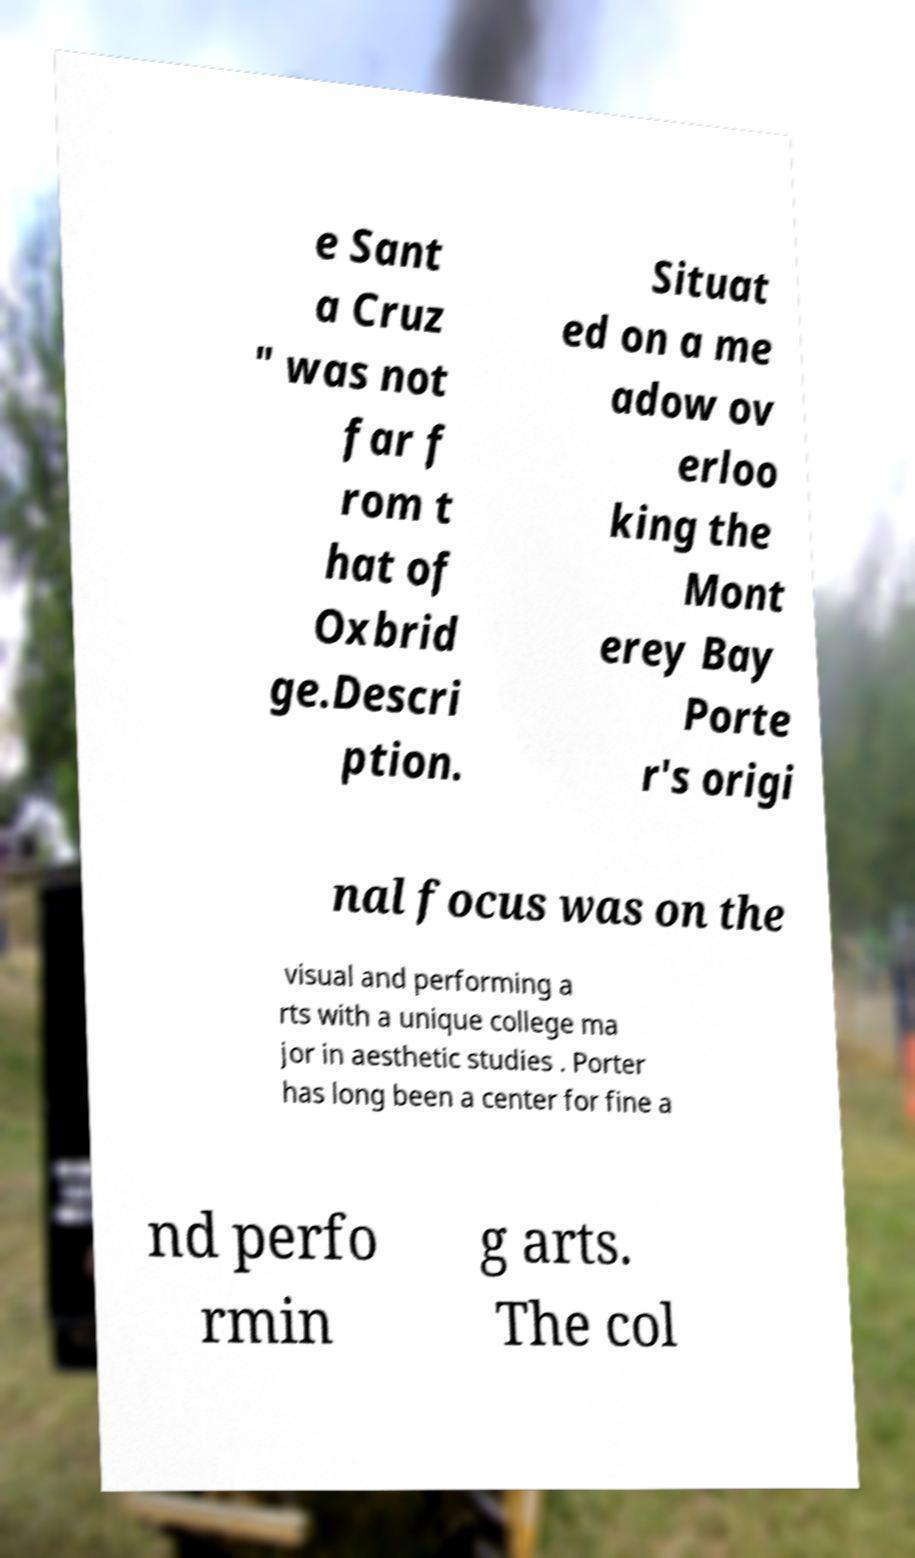Please read and relay the text visible in this image. What does it say? e Sant a Cruz " was not far f rom t hat of Oxbrid ge.Descri ption. Situat ed on a me adow ov erloo king the Mont erey Bay Porte r's origi nal focus was on the visual and performing a rts with a unique college ma jor in aesthetic studies . Porter has long been a center for fine a nd perfo rmin g arts. The col 